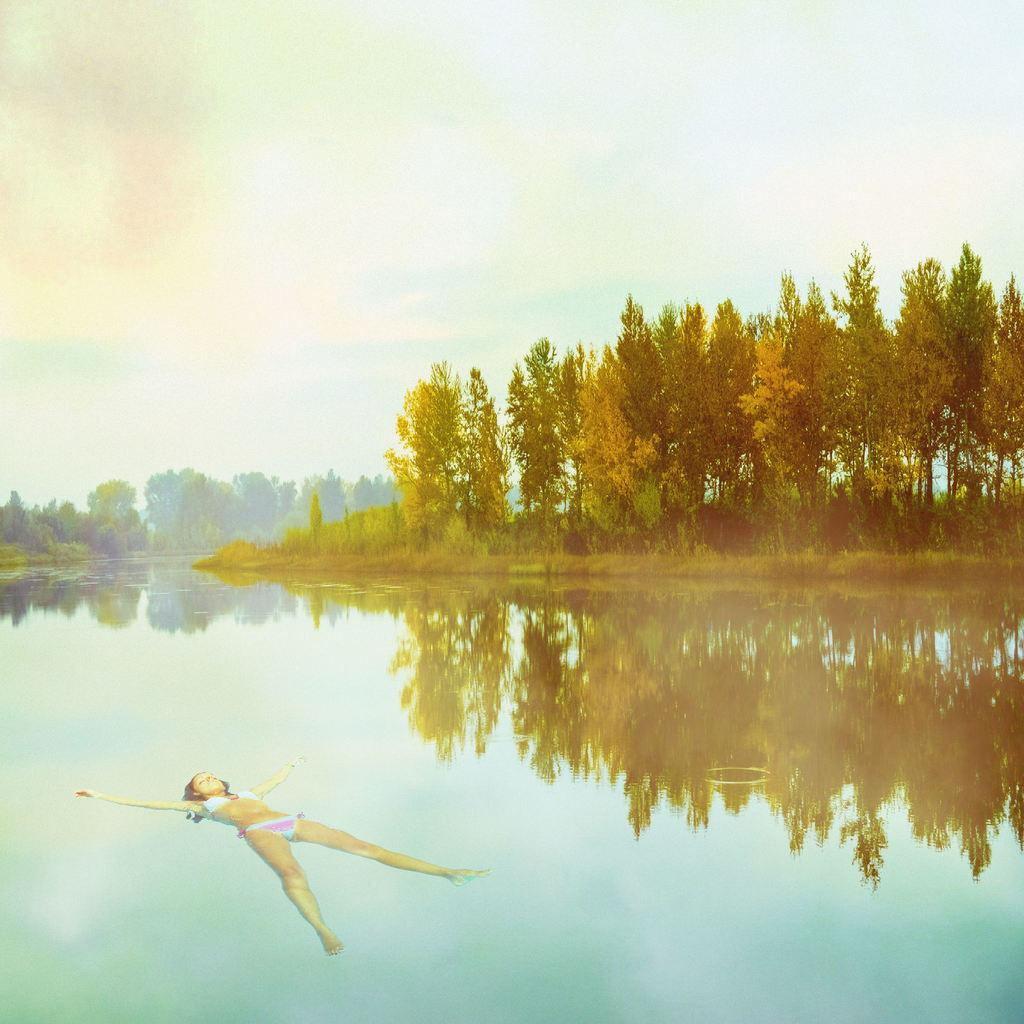What is the woman doing in the image? The woman is in the water. What can be seen in the background of the image? There are trees and the sky visible in the background of the image. How many rabbits can be seen in the image? There are no rabbits present in the image. What type of boot is the woman wearing in the image? The woman is not wearing any boots in the image, as she is in the water. 